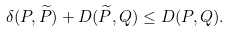Convert formula to latex. <formula><loc_0><loc_0><loc_500><loc_500>\delta ( P , \widetilde { P } ) + D ( \widetilde { P } , Q ) \leq D ( P , Q ) .</formula> 